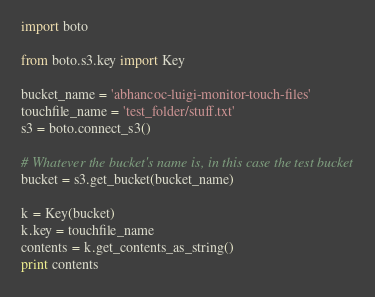<code> <loc_0><loc_0><loc_500><loc_500><_Python_>import boto

from boto.s3.key import Key

bucket_name = 'abhancoc-luigi-monitor-touch-files'
touchfile_name = 'test_folder/stuff.txt'
s3 = boto.connect_s3()

# Whatever the bucket's name is, in this case the test bucket
bucket = s3.get_bucket(bucket_name)

k = Key(bucket)
k.key = touchfile_name
contents = k.get_contents_as_string()
print contents
</code> 